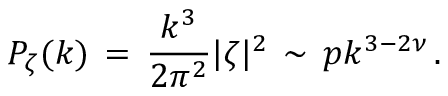<formula> <loc_0><loc_0><loc_500><loc_500>P _ { \zeta } ( k ) \, = \, { \frac { k ^ { 3 } } { 2 \pi ^ { 2 } } } | \zeta | ^ { 2 } \, \sim \, p k ^ { 3 - 2 \nu } \, .</formula> 